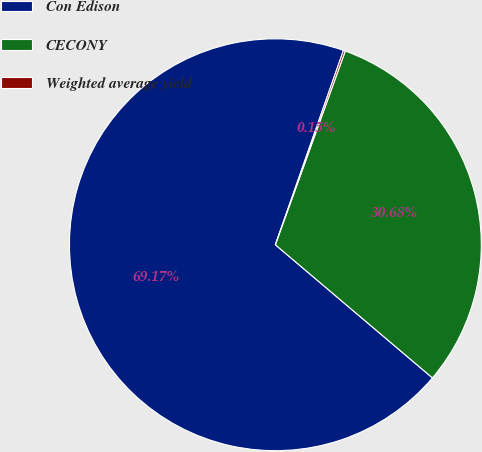Convert chart to OTSL. <chart><loc_0><loc_0><loc_500><loc_500><pie_chart><fcel>Con Edison<fcel>CECONY<fcel>Weighted average yield<nl><fcel>69.18%<fcel>30.68%<fcel>0.15%<nl></chart> 